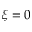<formula> <loc_0><loc_0><loc_500><loc_500>\xi = 0</formula> 